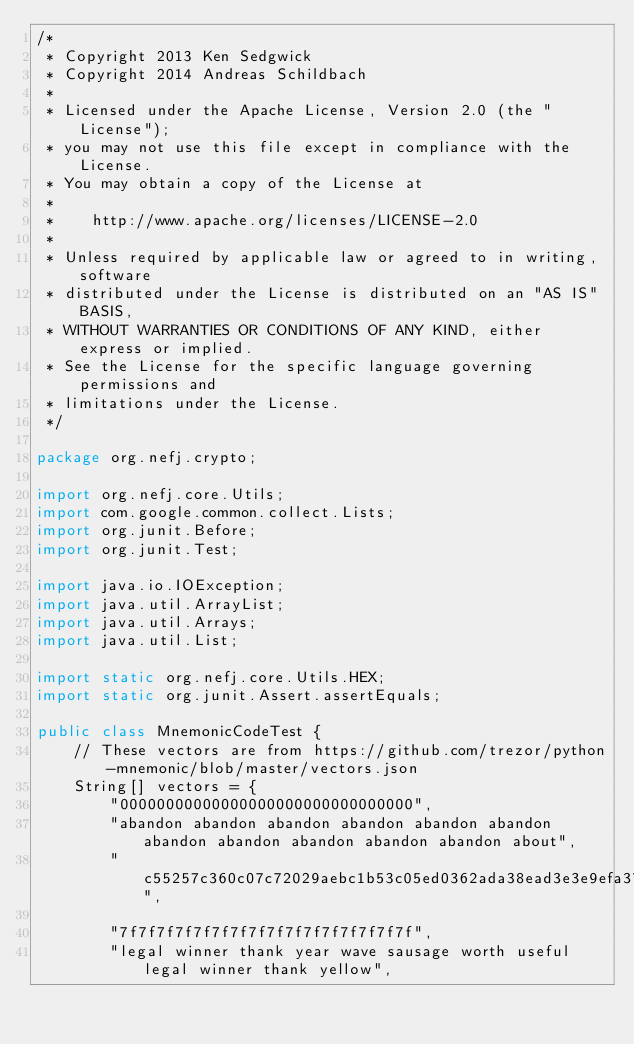<code> <loc_0><loc_0><loc_500><loc_500><_Java_>/*
 * Copyright 2013 Ken Sedgwick
 * Copyright 2014 Andreas Schildbach
 *
 * Licensed under the Apache License, Version 2.0 (the "License");
 * you may not use this file except in compliance with the License.
 * You may obtain a copy of the License at
 *
 *    http://www.apache.org/licenses/LICENSE-2.0
 *
 * Unless required by applicable law or agreed to in writing, software
 * distributed under the License is distributed on an "AS IS" BASIS,
 * WITHOUT WARRANTIES OR CONDITIONS OF ANY KIND, either express or implied.
 * See the License for the specific language governing permissions and
 * limitations under the License.
 */

package org.nefj.crypto;

import org.nefj.core.Utils;
import com.google.common.collect.Lists;
import org.junit.Before;
import org.junit.Test;

import java.io.IOException;
import java.util.ArrayList;
import java.util.Arrays;
import java.util.List;

import static org.nefj.core.Utils.HEX;
import static org.junit.Assert.assertEquals;

public class MnemonicCodeTest {
    // These vectors are from https://github.com/trezor/python-mnemonic/blob/master/vectors.json
    String[] vectors = {
        "00000000000000000000000000000000",
        "abandon abandon abandon abandon abandon abandon abandon abandon abandon abandon abandon about",
        "c55257c360c07c72029aebc1b53c05ed0362ada38ead3e3e9efa3708e53495531f09a6987599d18264c1e1c92f2cf141630c7a3c4ab7c81b2f001698e7463b04",

        "7f7f7f7f7f7f7f7f7f7f7f7f7f7f7f7f",
        "legal winner thank year wave sausage worth useful legal winner thank yellow",</code> 